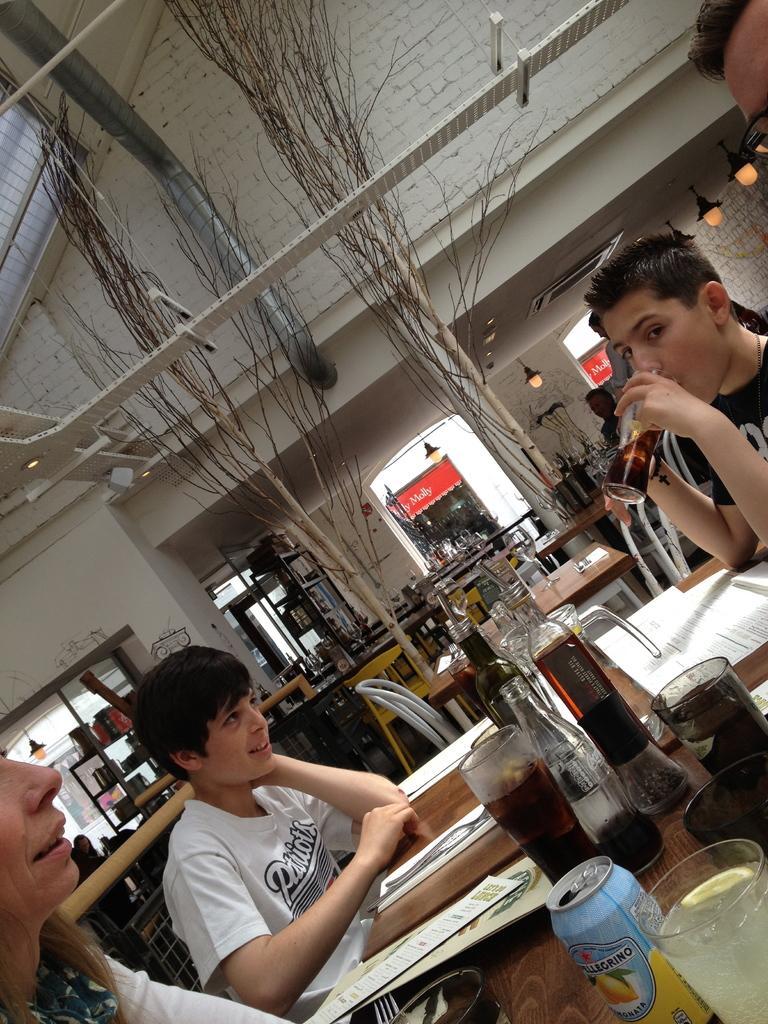In one or two sentences, can you explain what this image depicts? In this image there are three persons sitting around the table. On the table there are glasses,jars,papers,menu cards,spoons cans on it. At the top there is ceiling. In the background there are so many tables. There is a pipe at the top. There are lights which are hanged to the roof. In the background there are shelves in which there are jars and vessels. 